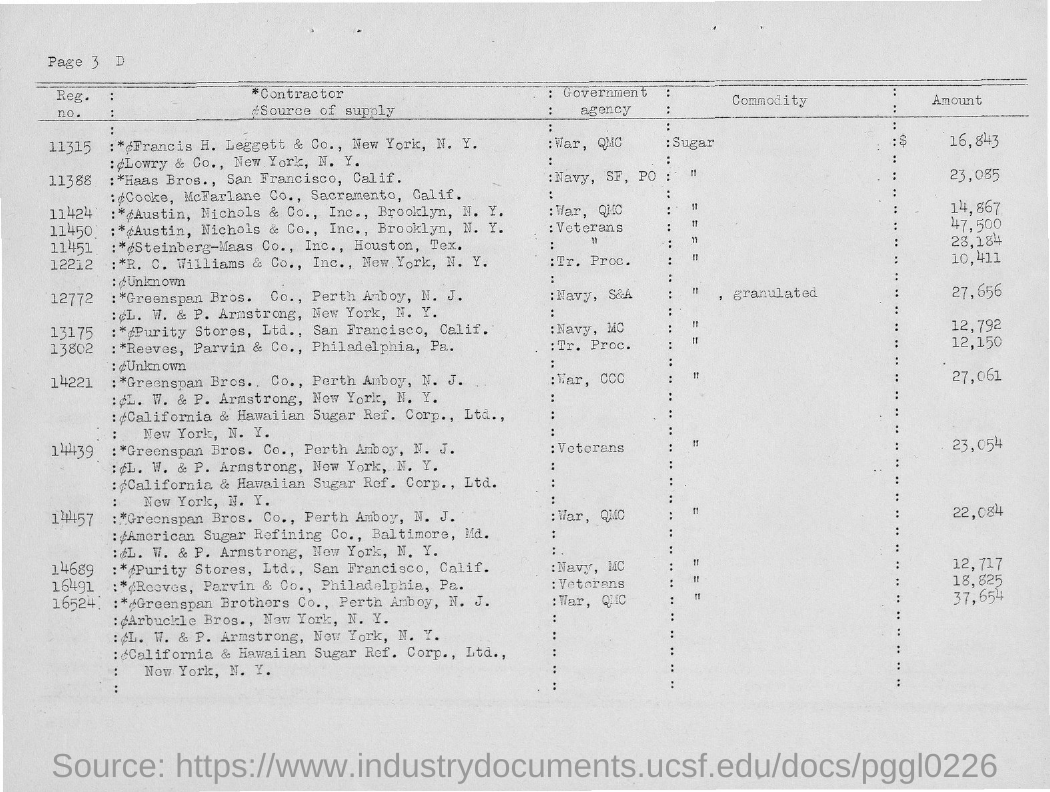What is the Source of supply of Haas Bros., San Francisco, Calif?
Your answer should be very brief. Cooke, McFarlane Co., Sacramento, Calif. Which is the Government agency to which "Haas Bros., San Francisco, Calif " supply?
Give a very brief answer. Navy,  SF, PO. What is the "amount" of the commodity supplied by Haas Bros.?
Your answer should be very brief. 23,085. What is the Reg.no. of "Haas Bros. "?
Provide a short and direct response. 11388. What is the name of the first Contractor mentioned in the table?
Provide a succinct answer. Francis H. Leggett & Co., New York, N. Y. Which "Government agency" does " Lowry & Co., Newyork, N.Y. " supply?
Provide a succinct answer. War, QMC. Who is the contractor for source of supply - "Cooke, Mc Farlane Co., Sacramento, Calif."?
Give a very brief answer. Haas Bros., San Francisco, Calif. Which is the last  Reg.no. given in this this page?
Keep it short and to the point. 16524. 